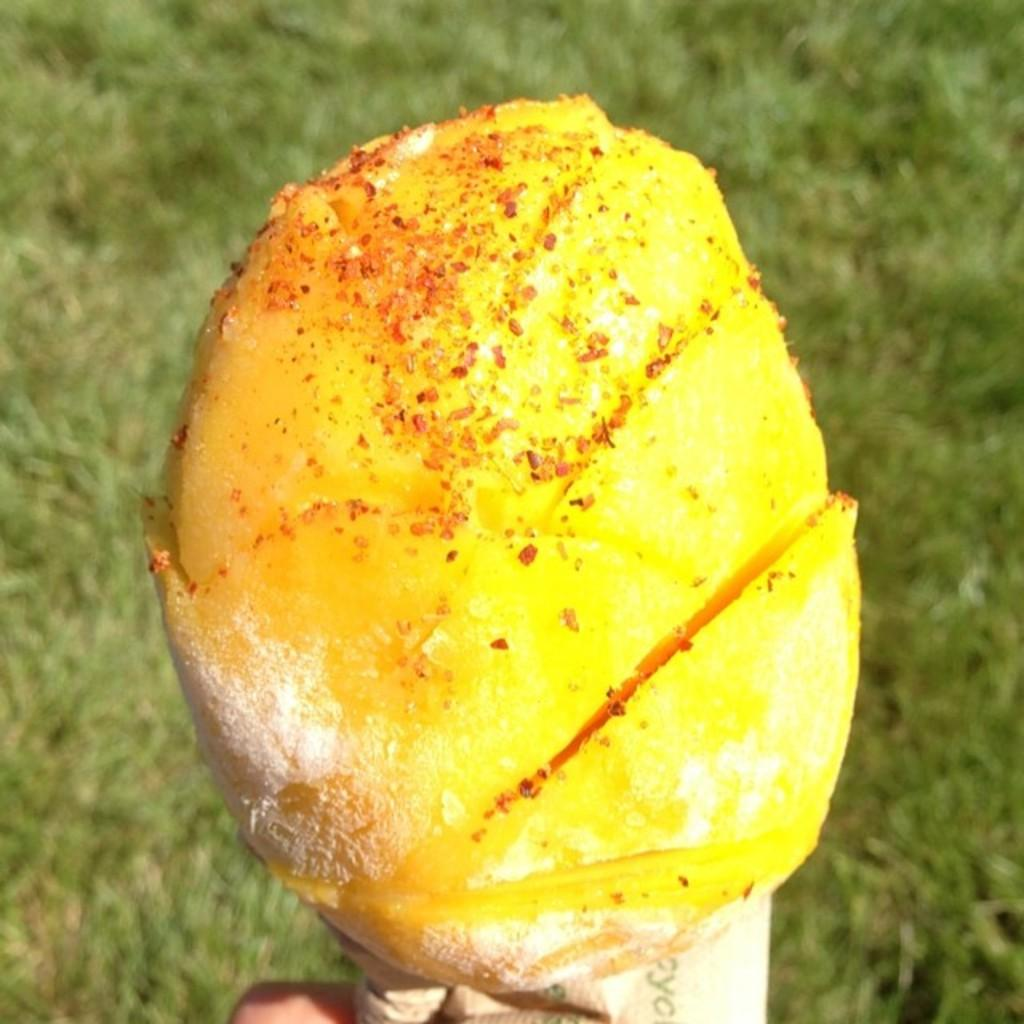What is the main subject of the image? There is a food item in the image. Who or what is holding the food item? A human hand is holding the food item. What type of surface can be seen in the image? There is grass visible on the ground in the image. Can you describe the wind patterns in the image? There is no information about wind patterns in the image, as it focuses on a food item being held by a human hand and the grassy ground. 